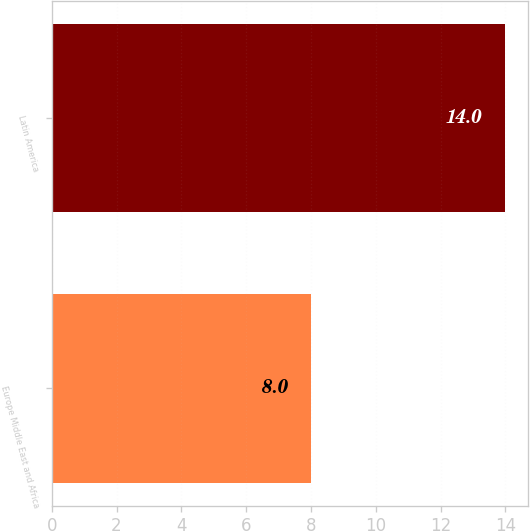Convert chart to OTSL. <chart><loc_0><loc_0><loc_500><loc_500><bar_chart><fcel>Europe Middle East and Africa<fcel>Latin America<nl><fcel>8<fcel>14<nl></chart> 